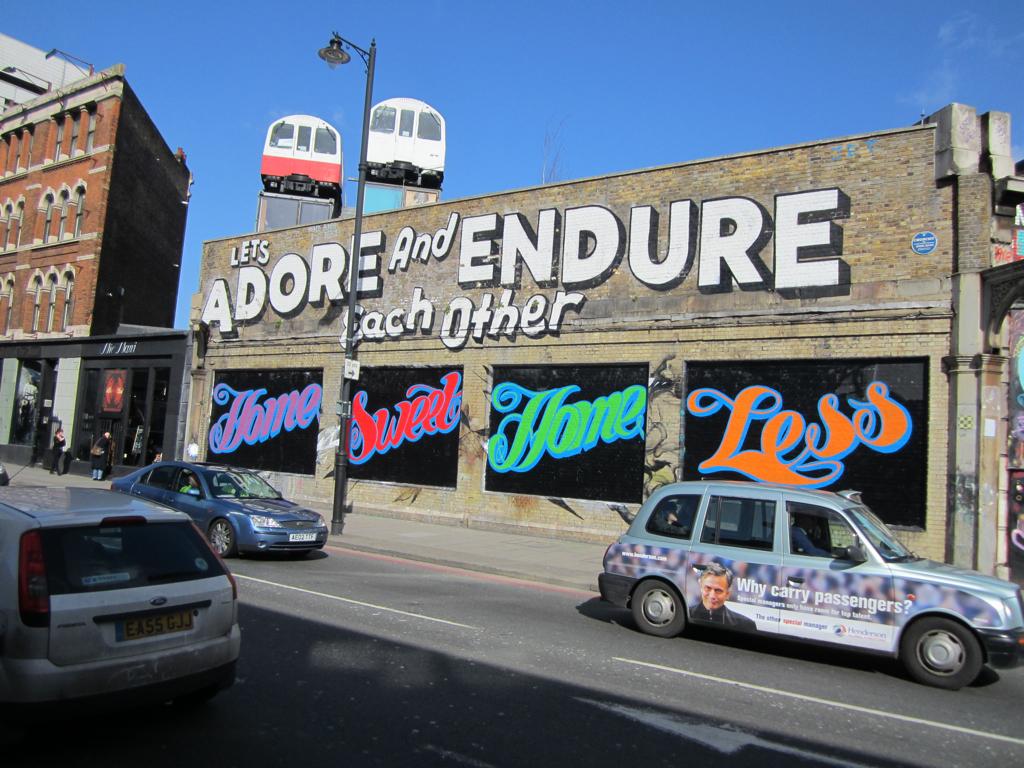What word is written in orange?
Your response must be concise. Less. What should we do with eachother?
Offer a very short reply. Adore and endure. 